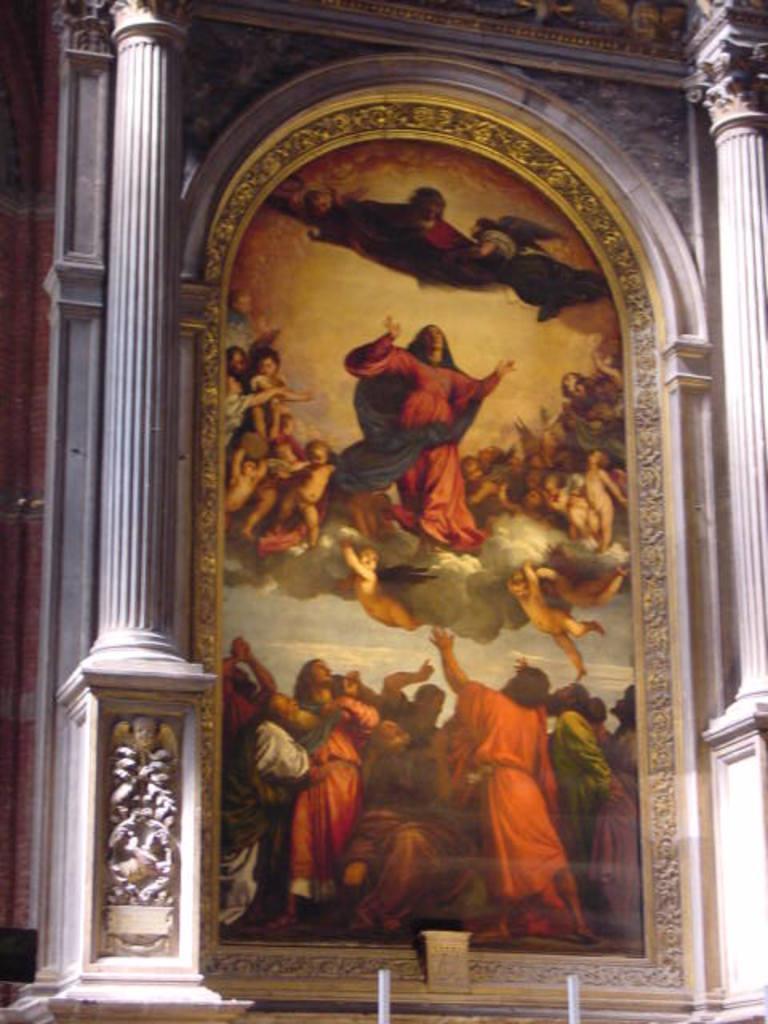How would you summarize this image in a sentence or two? In this picture we can see a photo frame on the wall, here we can see a group of people and pillars. 